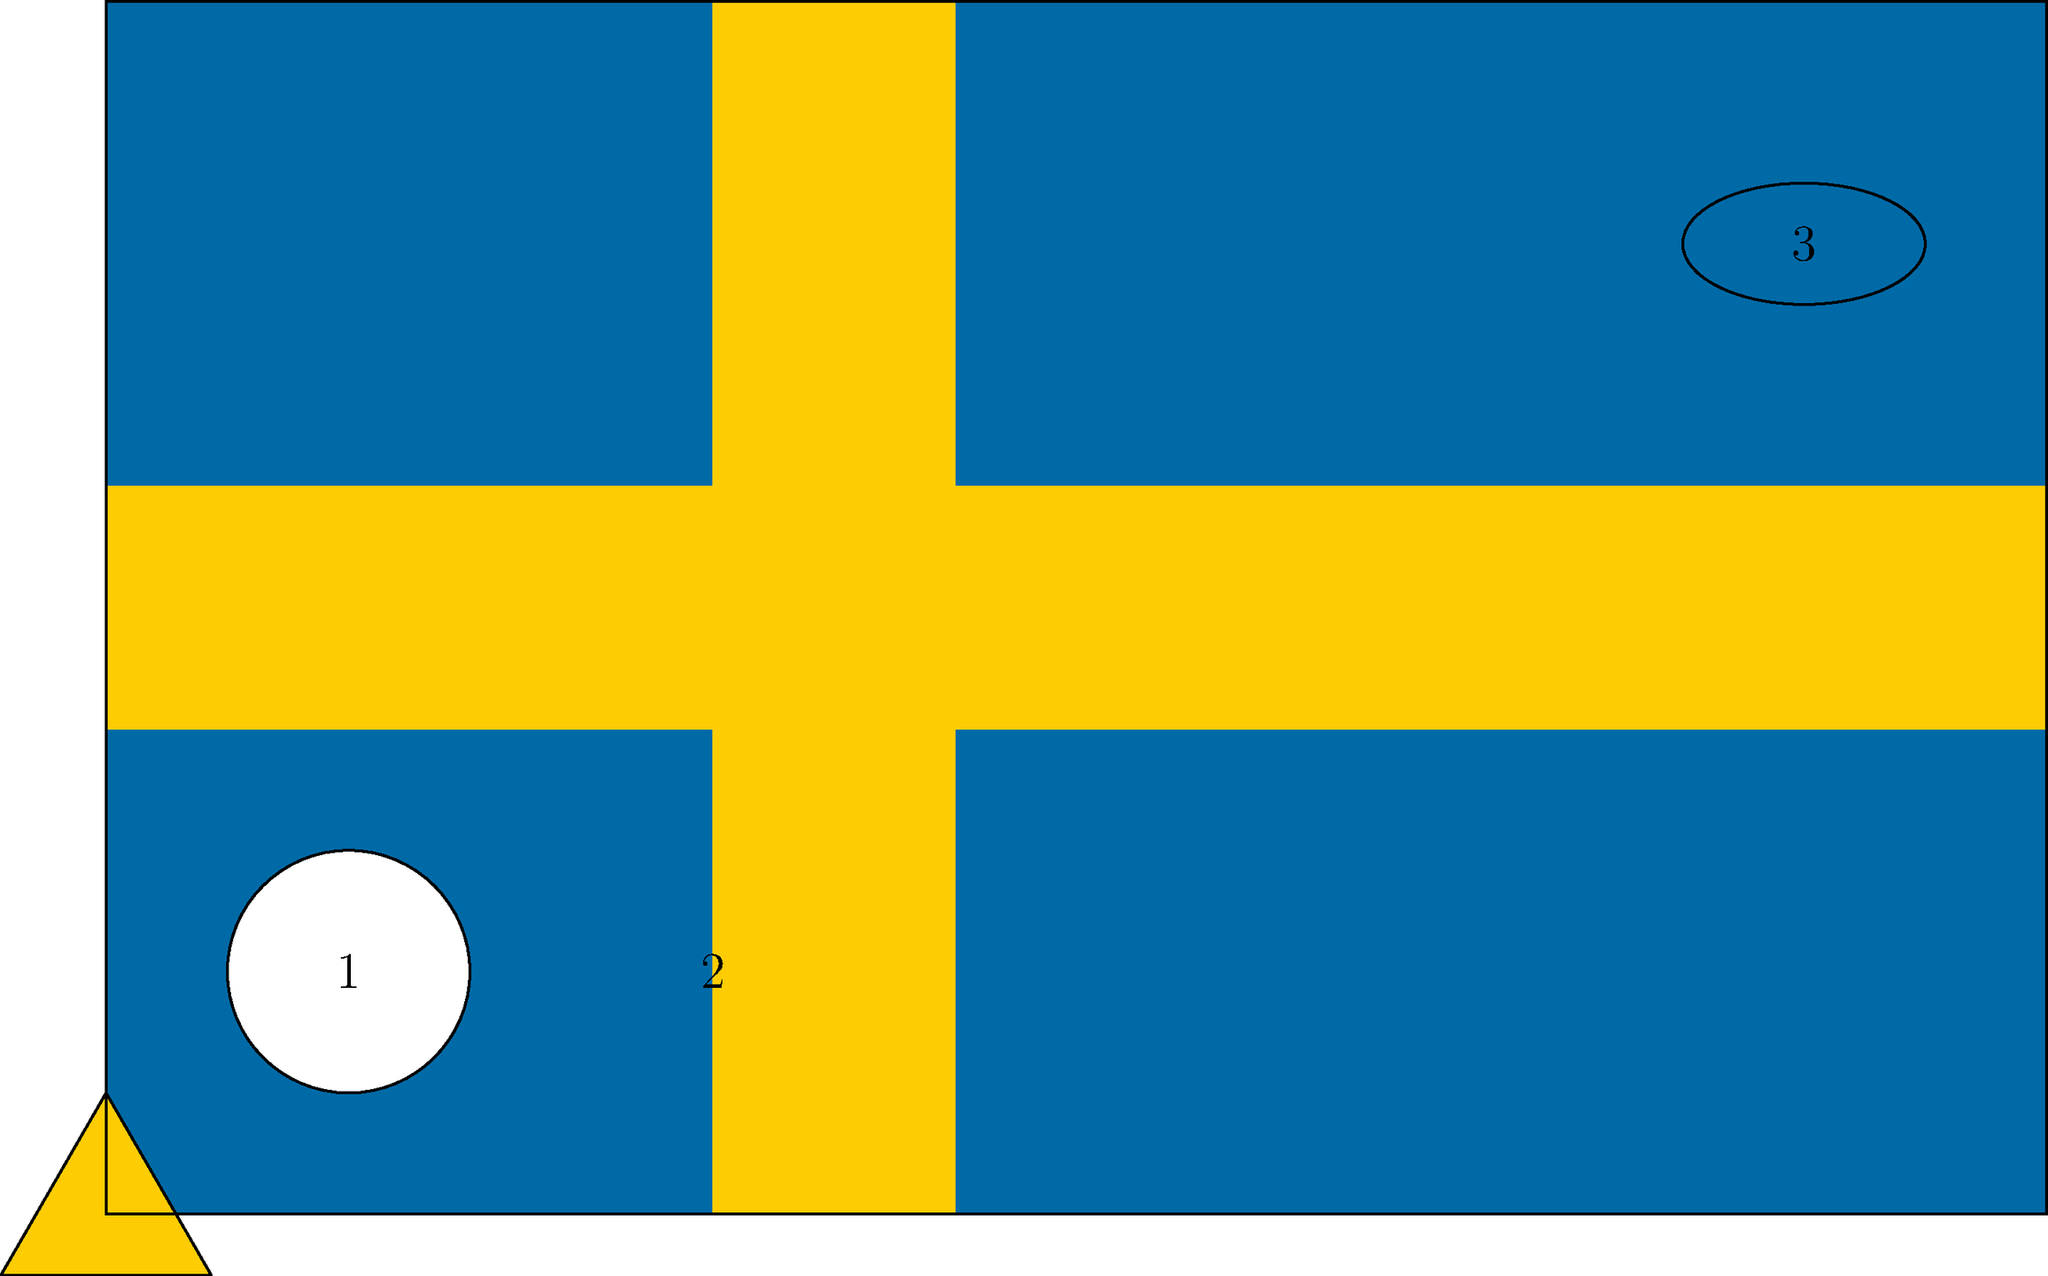In this visual puzzle based on the Swedish flag, three geometric shapes are superimposed on the flag. If the area of shape 1 is $\pi$ cm², what is the total area of all three shapes in cm²? (Assume the triangle is equilateral with a side length equal to the diameter of shape 1, and shape 3 is an ellipse with a major axis twice the length of its minor axis.) Let's approach this step-by-step:

1. Shape 1 is a circle with area $\pi$ cm². Let's find its radius:
   $A = \pi r^2$
   $\pi = \pi r^2$
   $r = 1$ cm

2. Shape 2 is an equilateral triangle. Its side length is equal to the diameter of shape 1, which is 2 cm.
   Area of an equilateral triangle: $A = \frac{\sqrt{3}}{4}a^2$
   where $a$ is the side length.
   $A_2 = \frac{\sqrt{3}}{4}(2)^2 = \sqrt{3}$ cm²

3. Shape 3 is an ellipse. If the major axis is twice the minor axis, and the area of an ellipse is $\pi ab$ where $a$ and $b$ are the semi-major and semi-minor axes:
   Let the minor axis be $x$, then the major axis is $2x$.
   Area = $\pi(\frac{x}{2})(\frac{2x}{2}) = \frac{\pi x^2}{2}$
   We're told this area is half of shape 1's area:
   $\frac{\pi x^2}{2} = \frac{\pi}{2}$
   $x^2 = 1$
   $x = 1$
   So the area of shape 3 is $\frac{\pi}{2}$ cm²

4. Total area = Area of shape 1 + Area of shape 2 + Area of shape 3
               = $\pi + \sqrt{3} + \frac{\pi}{2}$
               = $\frac{3\pi}{2} + \sqrt{3}$ cm²
Answer: $\frac{3\pi}{2} + \sqrt{3}$ cm² 